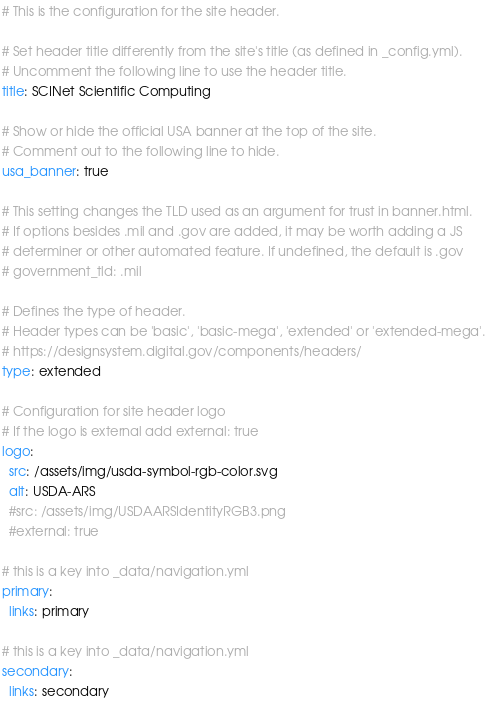Convert code to text. <code><loc_0><loc_0><loc_500><loc_500><_YAML_># This is the configuration for the site header.

# Set header title differently from the site's title (as defined in _config.yml).
# Uncomment the following line to use the header title.
title: SCINet Scientific Computing

# Show or hide the official USA banner at the top of the site.
# Comment out to the following line to hide.
usa_banner: true

# This setting changes the TLD used as an argument for trust in banner.html.
# If options besides .mil and .gov are added, it may be worth adding a JS
# determiner or other automated feature. If undefined, the default is .gov
# government_tld: .mil

# Defines the type of header.
# Header types can be 'basic', 'basic-mega', 'extended' or 'extended-mega'.
# https://designsystem.digital.gov/components/headers/
type: extended

# Configuration for site header logo
# If the logo is external add external: true
logo:
  src: /assets/img/usda-symbol-rgb-color.svg
  alt: USDA-ARS
  #src: /assets/img/USDAARSIdentityRGB3.png
  #external: true

# this is a key into _data/navigation.yml
primary:
  links: primary

# this is a key into _data/navigation.yml
secondary:
  links: secondary
</code> 